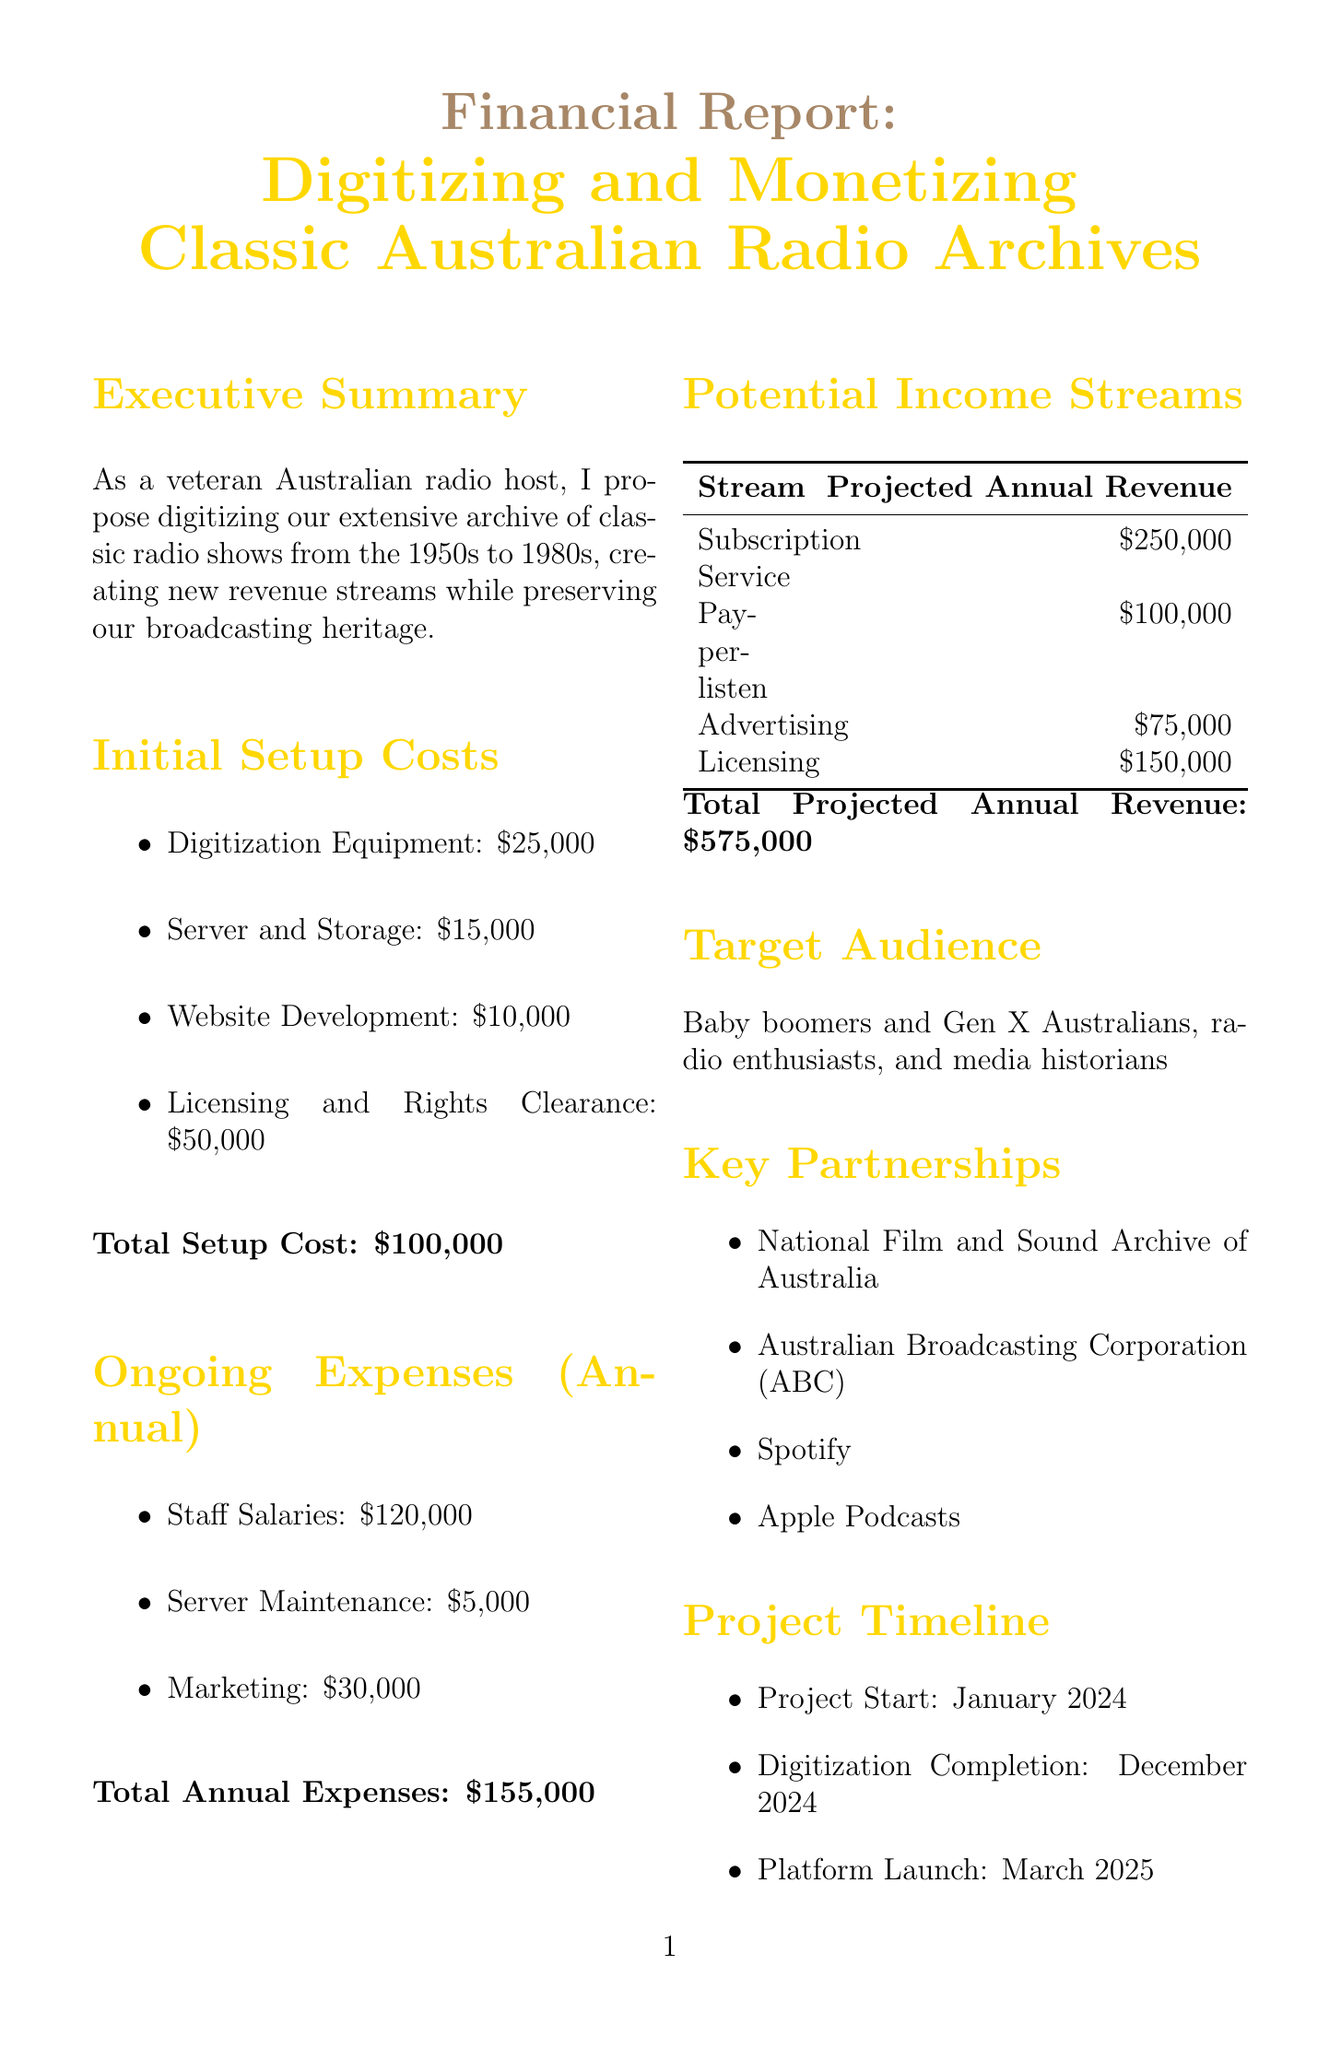What is the project title? The project title is explicitly stated at the beginning of the document.
Answer: Digitizing and Monetizing Classic Australian Radio Archives What is the total setup cost? The total setup cost is calculated by summing all initial setup costs listed in the document.
Answer: $100,000 What are the projected annual revenues from the subscription service? The document specifies the projected annual revenue for the subscription service directly.
Answer: $250,000 What is the expected completion date for digitization? The digitization completion date is explicitly mentioned in the project timeline section.
Answer: December 2024 Who are the target audiences for this project? The document lists the target audience explicitly in a dedicated section.
Answer: Baby boomers and Gen X Australians, radio enthusiasts, and media historians What is the projected break-even timeframe? The document mentions the break-even projection in the ROI projection section.
Answer: 18 months What are the ongoing expenses for staff salaries? The staff salaries figure is detailed in the ongoing expenses section of the document.
Answer: $120,000 Which organization is listed as a key partnership? The document lists key partnerships, and both organizations are mentioned.
Answer: National Film and Sound Archive of Australia What is the projected income from licensing rights? The document states this figure explicitly under potential income streams.
Answer: $150,000 